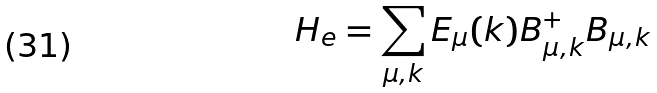Convert formula to latex. <formula><loc_0><loc_0><loc_500><loc_500>H _ { e } = \sum _ { \mu , k } E _ { \mu } ( k ) B _ { \mu , k } ^ { + } B _ { \mu , k }</formula> 